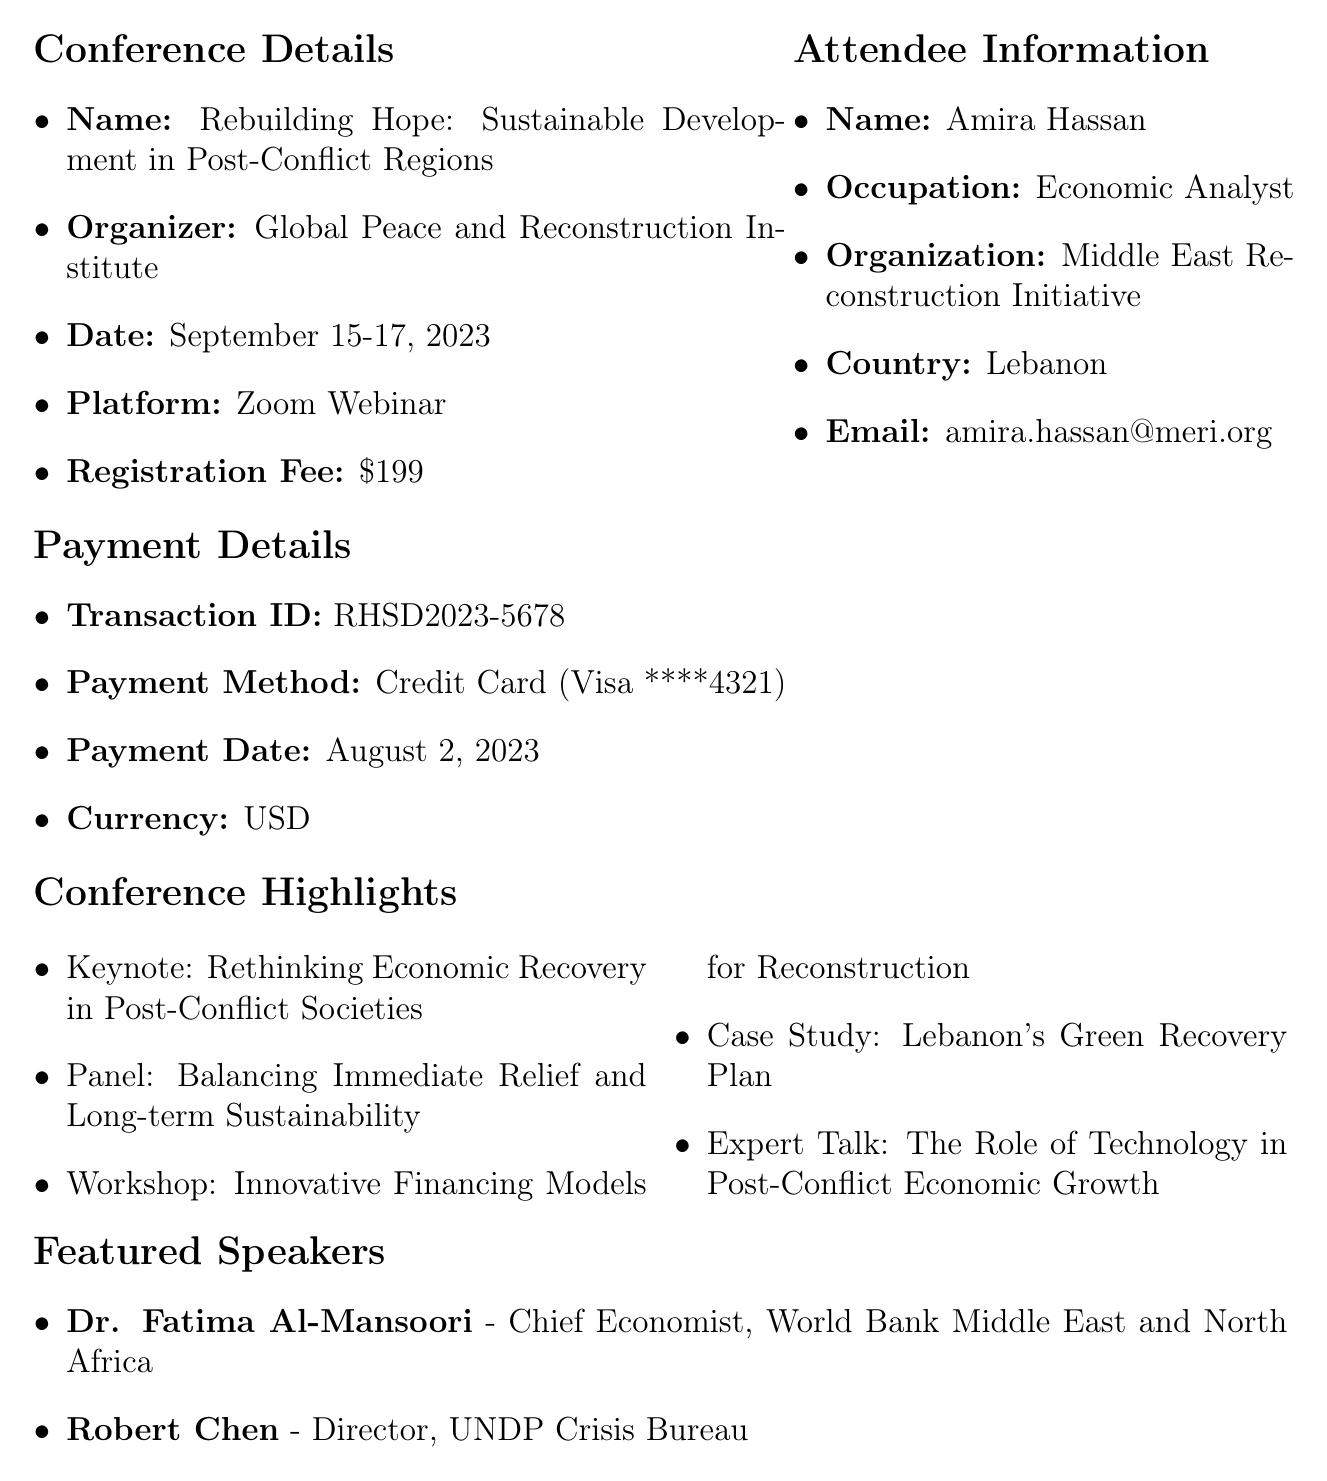What is the name of the conference? The name of the conference is explicitly stated in the document, which is "Rebuilding Hope: Sustainable Development in Post-Conflict Regions."
Answer: Rebuilding Hope: Sustainable Development in Post-Conflict Regions Who is the organizer of the conference? The organizer of the conference is mentioned in the details as "Global Peace and Reconstruction Institute."
Answer: Global Peace and Reconstruction Institute What is the registration fee for the conference? The registration fee is clearly listed in the document as "$199."
Answer: $199 Which payment method was used for the registration? The payment method is explicitly recorded in the payment details as "Credit Card."
Answer: Credit Card What is the date of the conference? The dates of the conference are provided in the details, which are "September 15-17, 2023."
Answer: September 15-17, 2023 What benefit is provided for networking? The document mentions "Networking opportunities with global experts and practitioners" as a benefit.
Answer: Networking opportunities with global experts and practitioners Who is one of the featured speakers? The document lists Dr. Fatima Al-Mansoori as one of the featured speakers.
Answer: Dr. Fatima Al-Mansoori What topic will be covered on Day 2 of the conference? The topic for Day 2 mentioned in the agenda includes "Interactive Session: Engaging Local Communities in Sustainable Development."
Answer: Interactive Session: Engaging Local Communities in Sustainable Development What special note is highlighted for attendees? The special note outlines the importance of attendees’ unique experiences, especially their perspective as war survivors.
Answer: Your unique perspective as a war survivor will be highly valued in our discussions 